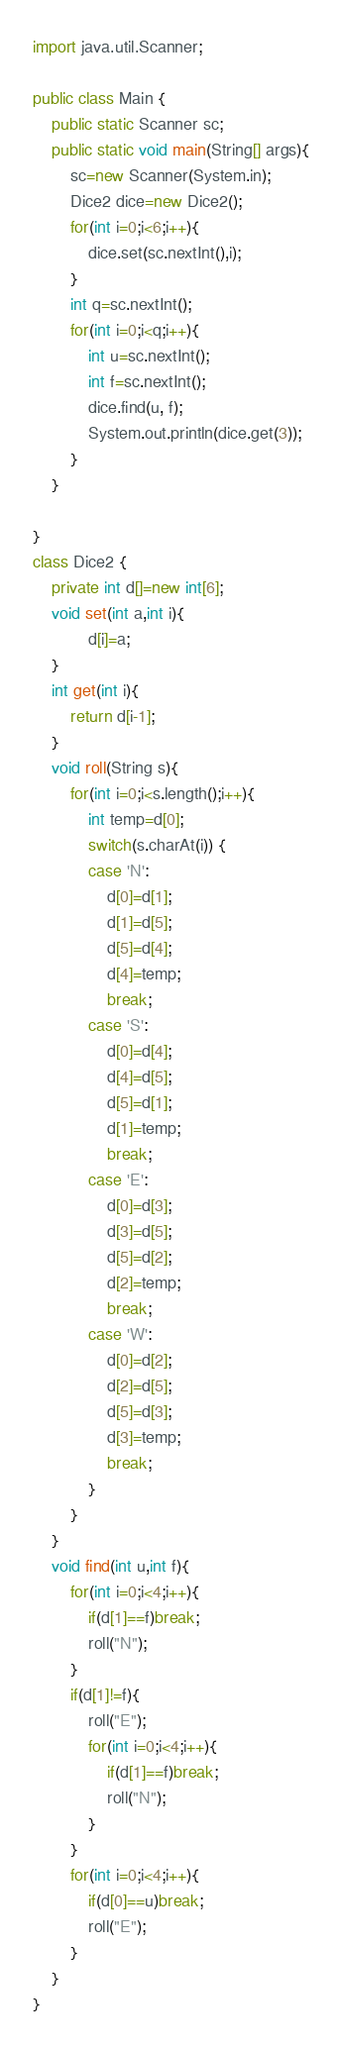Convert code to text. <code><loc_0><loc_0><loc_500><loc_500><_Java_>import java.util.Scanner;

public class Main {
	public static Scanner sc;
	public static void main(String[] args){
		sc=new Scanner(System.in);
		Dice2 dice=new Dice2();
		for(int i=0;i<6;i++){
			dice.set(sc.nextInt(),i);
		}
		int q=sc.nextInt();
		for(int i=0;i<q;i++){
			int u=sc.nextInt();
			int f=sc.nextInt();
			dice.find(u, f);
			System.out.println(dice.get(3));
		}
	}

}
class Dice2 {
	private int d[]=new int[6];
	void set(int a,int i){
			d[i]=a;
	}
	int get(int i){
		return d[i-1];
	}
	void roll(String s){
		for(int i=0;i<s.length();i++){
			int temp=d[0];
			switch(s.charAt(i)) {
			case 'N':
				d[0]=d[1];
				d[1]=d[5];
				d[5]=d[4];
				d[4]=temp;
				break;
			case 'S':
				d[0]=d[4];
				d[4]=d[5];
				d[5]=d[1];
				d[1]=temp;
				break;
			case 'E':
				d[0]=d[3];
				d[3]=d[5];
				d[5]=d[2];
				d[2]=temp;
				break;
			case 'W':
				d[0]=d[2];
				d[2]=d[5];
				d[5]=d[3];
				d[3]=temp;
				break;
			}
		}
	}
	void find(int u,int f){
		for(int i=0;i<4;i++){
			if(d[1]==f)break;
			roll("N");
		}
		if(d[1]!=f){
			roll("E");
			for(int i=0;i<4;i++){
				if(d[1]==f)break;
				roll("N");
			}
		}
		for(int i=0;i<4;i++){
			if(d[0]==u)break;
			roll("E");
		}
	}
}</code> 